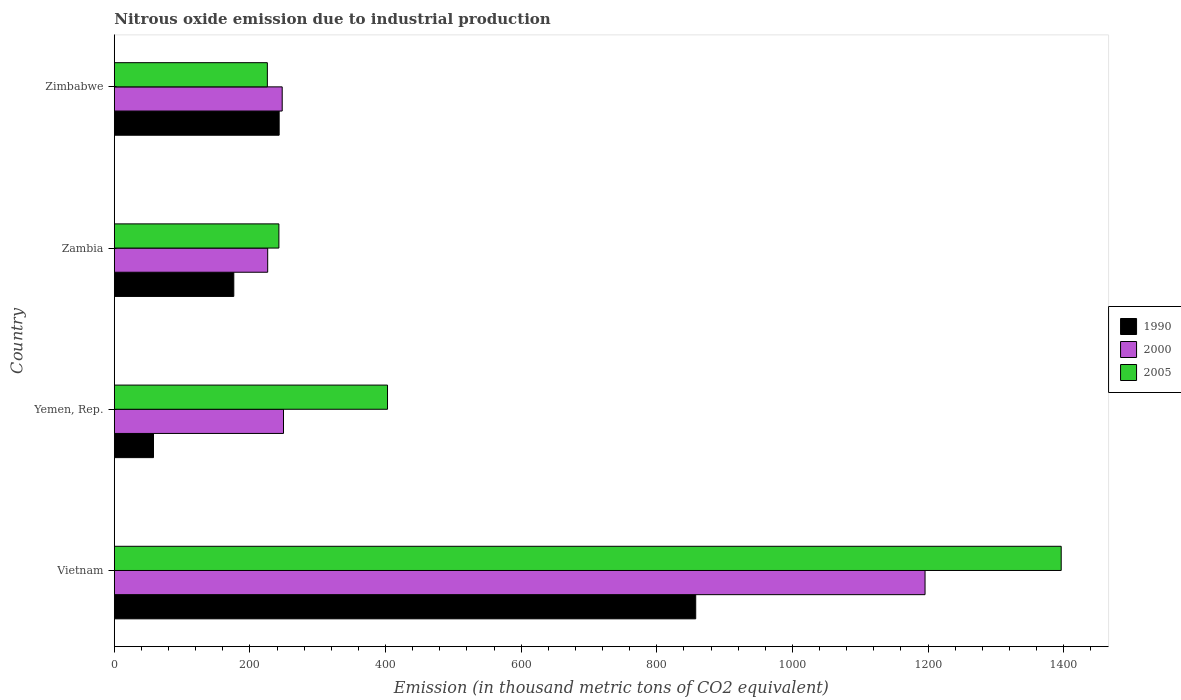How many different coloured bars are there?
Keep it short and to the point. 3. Are the number of bars on each tick of the Y-axis equal?
Ensure brevity in your answer.  Yes. How many bars are there on the 1st tick from the top?
Your answer should be compact. 3. How many bars are there on the 1st tick from the bottom?
Give a very brief answer. 3. What is the label of the 2nd group of bars from the top?
Give a very brief answer. Zambia. What is the amount of nitrous oxide emitted in 1990 in Zambia?
Provide a short and direct response. 176.2. Across all countries, what is the maximum amount of nitrous oxide emitted in 1990?
Provide a short and direct response. 857.4. Across all countries, what is the minimum amount of nitrous oxide emitted in 2000?
Ensure brevity in your answer.  226.2. In which country was the amount of nitrous oxide emitted in 2005 maximum?
Offer a terse response. Vietnam. In which country was the amount of nitrous oxide emitted in 1990 minimum?
Make the answer very short. Yemen, Rep. What is the total amount of nitrous oxide emitted in 1990 in the graph?
Provide a short and direct response. 1334.5. What is the difference between the amount of nitrous oxide emitted in 2005 in Yemen, Rep. and that in Zambia?
Provide a succinct answer. 160.2. What is the difference between the amount of nitrous oxide emitted in 2005 in Vietnam and the amount of nitrous oxide emitted in 1990 in Zambia?
Offer a terse response. 1220.2. What is the average amount of nitrous oxide emitted in 2000 per country?
Offer a terse response. 479.72. What is the difference between the amount of nitrous oxide emitted in 2000 and amount of nitrous oxide emitted in 1990 in Vietnam?
Offer a very short reply. 338.2. In how many countries, is the amount of nitrous oxide emitted in 1990 greater than 1400 thousand metric tons?
Keep it short and to the point. 0. What is the ratio of the amount of nitrous oxide emitted in 1990 in Yemen, Rep. to that in Zambia?
Provide a short and direct response. 0.33. Is the difference between the amount of nitrous oxide emitted in 2000 in Yemen, Rep. and Zambia greater than the difference between the amount of nitrous oxide emitted in 1990 in Yemen, Rep. and Zambia?
Your response must be concise. Yes. What is the difference between the highest and the second highest amount of nitrous oxide emitted in 2000?
Your response must be concise. 946.1. What is the difference between the highest and the lowest amount of nitrous oxide emitted in 2000?
Provide a succinct answer. 969.4. What does the 1st bar from the bottom in Yemen, Rep. represents?
Offer a terse response. 1990. Is it the case that in every country, the sum of the amount of nitrous oxide emitted in 1990 and amount of nitrous oxide emitted in 2005 is greater than the amount of nitrous oxide emitted in 2000?
Provide a short and direct response. Yes. How many countries are there in the graph?
Keep it short and to the point. 4. What is the difference between two consecutive major ticks on the X-axis?
Your answer should be very brief. 200. Does the graph contain any zero values?
Your response must be concise. No. Where does the legend appear in the graph?
Provide a succinct answer. Center right. What is the title of the graph?
Provide a succinct answer. Nitrous oxide emission due to industrial production. Does "1979" appear as one of the legend labels in the graph?
Offer a terse response. No. What is the label or title of the X-axis?
Provide a short and direct response. Emission (in thousand metric tons of CO2 equivalent). What is the label or title of the Y-axis?
Your answer should be very brief. Country. What is the Emission (in thousand metric tons of CO2 equivalent) of 1990 in Vietnam?
Provide a succinct answer. 857.4. What is the Emission (in thousand metric tons of CO2 equivalent) in 2000 in Vietnam?
Give a very brief answer. 1195.6. What is the Emission (in thousand metric tons of CO2 equivalent) in 2005 in Vietnam?
Make the answer very short. 1396.4. What is the Emission (in thousand metric tons of CO2 equivalent) in 1990 in Yemen, Rep.?
Give a very brief answer. 57.8. What is the Emission (in thousand metric tons of CO2 equivalent) in 2000 in Yemen, Rep.?
Offer a very short reply. 249.5. What is the Emission (in thousand metric tons of CO2 equivalent) in 2005 in Yemen, Rep.?
Give a very brief answer. 402.9. What is the Emission (in thousand metric tons of CO2 equivalent) in 1990 in Zambia?
Your answer should be compact. 176.2. What is the Emission (in thousand metric tons of CO2 equivalent) of 2000 in Zambia?
Make the answer very short. 226.2. What is the Emission (in thousand metric tons of CO2 equivalent) of 2005 in Zambia?
Make the answer very short. 242.7. What is the Emission (in thousand metric tons of CO2 equivalent) in 1990 in Zimbabwe?
Ensure brevity in your answer.  243.1. What is the Emission (in thousand metric tons of CO2 equivalent) of 2000 in Zimbabwe?
Your response must be concise. 247.6. What is the Emission (in thousand metric tons of CO2 equivalent) of 2005 in Zimbabwe?
Keep it short and to the point. 225.7. Across all countries, what is the maximum Emission (in thousand metric tons of CO2 equivalent) in 1990?
Offer a very short reply. 857.4. Across all countries, what is the maximum Emission (in thousand metric tons of CO2 equivalent) of 2000?
Provide a succinct answer. 1195.6. Across all countries, what is the maximum Emission (in thousand metric tons of CO2 equivalent) in 2005?
Your answer should be very brief. 1396.4. Across all countries, what is the minimum Emission (in thousand metric tons of CO2 equivalent) in 1990?
Offer a terse response. 57.8. Across all countries, what is the minimum Emission (in thousand metric tons of CO2 equivalent) in 2000?
Your response must be concise. 226.2. Across all countries, what is the minimum Emission (in thousand metric tons of CO2 equivalent) of 2005?
Keep it short and to the point. 225.7. What is the total Emission (in thousand metric tons of CO2 equivalent) of 1990 in the graph?
Give a very brief answer. 1334.5. What is the total Emission (in thousand metric tons of CO2 equivalent) in 2000 in the graph?
Offer a terse response. 1918.9. What is the total Emission (in thousand metric tons of CO2 equivalent) in 2005 in the graph?
Your answer should be very brief. 2267.7. What is the difference between the Emission (in thousand metric tons of CO2 equivalent) in 1990 in Vietnam and that in Yemen, Rep.?
Your answer should be compact. 799.6. What is the difference between the Emission (in thousand metric tons of CO2 equivalent) of 2000 in Vietnam and that in Yemen, Rep.?
Provide a succinct answer. 946.1. What is the difference between the Emission (in thousand metric tons of CO2 equivalent) in 2005 in Vietnam and that in Yemen, Rep.?
Keep it short and to the point. 993.5. What is the difference between the Emission (in thousand metric tons of CO2 equivalent) of 1990 in Vietnam and that in Zambia?
Ensure brevity in your answer.  681.2. What is the difference between the Emission (in thousand metric tons of CO2 equivalent) of 2000 in Vietnam and that in Zambia?
Provide a short and direct response. 969.4. What is the difference between the Emission (in thousand metric tons of CO2 equivalent) of 2005 in Vietnam and that in Zambia?
Your answer should be compact. 1153.7. What is the difference between the Emission (in thousand metric tons of CO2 equivalent) of 1990 in Vietnam and that in Zimbabwe?
Offer a very short reply. 614.3. What is the difference between the Emission (in thousand metric tons of CO2 equivalent) in 2000 in Vietnam and that in Zimbabwe?
Your response must be concise. 948. What is the difference between the Emission (in thousand metric tons of CO2 equivalent) in 2005 in Vietnam and that in Zimbabwe?
Offer a very short reply. 1170.7. What is the difference between the Emission (in thousand metric tons of CO2 equivalent) of 1990 in Yemen, Rep. and that in Zambia?
Make the answer very short. -118.4. What is the difference between the Emission (in thousand metric tons of CO2 equivalent) of 2000 in Yemen, Rep. and that in Zambia?
Your response must be concise. 23.3. What is the difference between the Emission (in thousand metric tons of CO2 equivalent) of 2005 in Yemen, Rep. and that in Zambia?
Give a very brief answer. 160.2. What is the difference between the Emission (in thousand metric tons of CO2 equivalent) in 1990 in Yemen, Rep. and that in Zimbabwe?
Provide a short and direct response. -185.3. What is the difference between the Emission (in thousand metric tons of CO2 equivalent) of 2000 in Yemen, Rep. and that in Zimbabwe?
Provide a succinct answer. 1.9. What is the difference between the Emission (in thousand metric tons of CO2 equivalent) in 2005 in Yemen, Rep. and that in Zimbabwe?
Offer a very short reply. 177.2. What is the difference between the Emission (in thousand metric tons of CO2 equivalent) in 1990 in Zambia and that in Zimbabwe?
Give a very brief answer. -66.9. What is the difference between the Emission (in thousand metric tons of CO2 equivalent) in 2000 in Zambia and that in Zimbabwe?
Your answer should be very brief. -21.4. What is the difference between the Emission (in thousand metric tons of CO2 equivalent) in 1990 in Vietnam and the Emission (in thousand metric tons of CO2 equivalent) in 2000 in Yemen, Rep.?
Offer a terse response. 607.9. What is the difference between the Emission (in thousand metric tons of CO2 equivalent) in 1990 in Vietnam and the Emission (in thousand metric tons of CO2 equivalent) in 2005 in Yemen, Rep.?
Offer a terse response. 454.5. What is the difference between the Emission (in thousand metric tons of CO2 equivalent) of 2000 in Vietnam and the Emission (in thousand metric tons of CO2 equivalent) of 2005 in Yemen, Rep.?
Give a very brief answer. 792.7. What is the difference between the Emission (in thousand metric tons of CO2 equivalent) of 1990 in Vietnam and the Emission (in thousand metric tons of CO2 equivalent) of 2000 in Zambia?
Give a very brief answer. 631.2. What is the difference between the Emission (in thousand metric tons of CO2 equivalent) of 1990 in Vietnam and the Emission (in thousand metric tons of CO2 equivalent) of 2005 in Zambia?
Offer a terse response. 614.7. What is the difference between the Emission (in thousand metric tons of CO2 equivalent) of 2000 in Vietnam and the Emission (in thousand metric tons of CO2 equivalent) of 2005 in Zambia?
Your answer should be very brief. 952.9. What is the difference between the Emission (in thousand metric tons of CO2 equivalent) of 1990 in Vietnam and the Emission (in thousand metric tons of CO2 equivalent) of 2000 in Zimbabwe?
Keep it short and to the point. 609.8. What is the difference between the Emission (in thousand metric tons of CO2 equivalent) in 1990 in Vietnam and the Emission (in thousand metric tons of CO2 equivalent) in 2005 in Zimbabwe?
Your response must be concise. 631.7. What is the difference between the Emission (in thousand metric tons of CO2 equivalent) of 2000 in Vietnam and the Emission (in thousand metric tons of CO2 equivalent) of 2005 in Zimbabwe?
Give a very brief answer. 969.9. What is the difference between the Emission (in thousand metric tons of CO2 equivalent) of 1990 in Yemen, Rep. and the Emission (in thousand metric tons of CO2 equivalent) of 2000 in Zambia?
Provide a short and direct response. -168.4. What is the difference between the Emission (in thousand metric tons of CO2 equivalent) of 1990 in Yemen, Rep. and the Emission (in thousand metric tons of CO2 equivalent) of 2005 in Zambia?
Provide a short and direct response. -184.9. What is the difference between the Emission (in thousand metric tons of CO2 equivalent) in 2000 in Yemen, Rep. and the Emission (in thousand metric tons of CO2 equivalent) in 2005 in Zambia?
Offer a very short reply. 6.8. What is the difference between the Emission (in thousand metric tons of CO2 equivalent) of 1990 in Yemen, Rep. and the Emission (in thousand metric tons of CO2 equivalent) of 2000 in Zimbabwe?
Offer a very short reply. -189.8. What is the difference between the Emission (in thousand metric tons of CO2 equivalent) in 1990 in Yemen, Rep. and the Emission (in thousand metric tons of CO2 equivalent) in 2005 in Zimbabwe?
Your answer should be compact. -167.9. What is the difference between the Emission (in thousand metric tons of CO2 equivalent) in 2000 in Yemen, Rep. and the Emission (in thousand metric tons of CO2 equivalent) in 2005 in Zimbabwe?
Give a very brief answer. 23.8. What is the difference between the Emission (in thousand metric tons of CO2 equivalent) of 1990 in Zambia and the Emission (in thousand metric tons of CO2 equivalent) of 2000 in Zimbabwe?
Offer a terse response. -71.4. What is the difference between the Emission (in thousand metric tons of CO2 equivalent) of 1990 in Zambia and the Emission (in thousand metric tons of CO2 equivalent) of 2005 in Zimbabwe?
Ensure brevity in your answer.  -49.5. What is the difference between the Emission (in thousand metric tons of CO2 equivalent) in 2000 in Zambia and the Emission (in thousand metric tons of CO2 equivalent) in 2005 in Zimbabwe?
Your response must be concise. 0.5. What is the average Emission (in thousand metric tons of CO2 equivalent) of 1990 per country?
Your answer should be compact. 333.62. What is the average Emission (in thousand metric tons of CO2 equivalent) of 2000 per country?
Make the answer very short. 479.73. What is the average Emission (in thousand metric tons of CO2 equivalent) of 2005 per country?
Offer a very short reply. 566.92. What is the difference between the Emission (in thousand metric tons of CO2 equivalent) in 1990 and Emission (in thousand metric tons of CO2 equivalent) in 2000 in Vietnam?
Give a very brief answer. -338.2. What is the difference between the Emission (in thousand metric tons of CO2 equivalent) of 1990 and Emission (in thousand metric tons of CO2 equivalent) of 2005 in Vietnam?
Offer a terse response. -539. What is the difference between the Emission (in thousand metric tons of CO2 equivalent) of 2000 and Emission (in thousand metric tons of CO2 equivalent) of 2005 in Vietnam?
Your response must be concise. -200.8. What is the difference between the Emission (in thousand metric tons of CO2 equivalent) in 1990 and Emission (in thousand metric tons of CO2 equivalent) in 2000 in Yemen, Rep.?
Make the answer very short. -191.7. What is the difference between the Emission (in thousand metric tons of CO2 equivalent) in 1990 and Emission (in thousand metric tons of CO2 equivalent) in 2005 in Yemen, Rep.?
Provide a short and direct response. -345.1. What is the difference between the Emission (in thousand metric tons of CO2 equivalent) of 2000 and Emission (in thousand metric tons of CO2 equivalent) of 2005 in Yemen, Rep.?
Provide a short and direct response. -153.4. What is the difference between the Emission (in thousand metric tons of CO2 equivalent) in 1990 and Emission (in thousand metric tons of CO2 equivalent) in 2000 in Zambia?
Your answer should be very brief. -50. What is the difference between the Emission (in thousand metric tons of CO2 equivalent) in 1990 and Emission (in thousand metric tons of CO2 equivalent) in 2005 in Zambia?
Your response must be concise. -66.5. What is the difference between the Emission (in thousand metric tons of CO2 equivalent) of 2000 and Emission (in thousand metric tons of CO2 equivalent) of 2005 in Zambia?
Your answer should be very brief. -16.5. What is the difference between the Emission (in thousand metric tons of CO2 equivalent) in 2000 and Emission (in thousand metric tons of CO2 equivalent) in 2005 in Zimbabwe?
Make the answer very short. 21.9. What is the ratio of the Emission (in thousand metric tons of CO2 equivalent) of 1990 in Vietnam to that in Yemen, Rep.?
Offer a very short reply. 14.83. What is the ratio of the Emission (in thousand metric tons of CO2 equivalent) in 2000 in Vietnam to that in Yemen, Rep.?
Your response must be concise. 4.79. What is the ratio of the Emission (in thousand metric tons of CO2 equivalent) in 2005 in Vietnam to that in Yemen, Rep.?
Your answer should be compact. 3.47. What is the ratio of the Emission (in thousand metric tons of CO2 equivalent) of 1990 in Vietnam to that in Zambia?
Ensure brevity in your answer.  4.87. What is the ratio of the Emission (in thousand metric tons of CO2 equivalent) of 2000 in Vietnam to that in Zambia?
Your response must be concise. 5.29. What is the ratio of the Emission (in thousand metric tons of CO2 equivalent) of 2005 in Vietnam to that in Zambia?
Your response must be concise. 5.75. What is the ratio of the Emission (in thousand metric tons of CO2 equivalent) in 1990 in Vietnam to that in Zimbabwe?
Your answer should be compact. 3.53. What is the ratio of the Emission (in thousand metric tons of CO2 equivalent) of 2000 in Vietnam to that in Zimbabwe?
Your answer should be very brief. 4.83. What is the ratio of the Emission (in thousand metric tons of CO2 equivalent) in 2005 in Vietnam to that in Zimbabwe?
Ensure brevity in your answer.  6.19. What is the ratio of the Emission (in thousand metric tons of CO2 equivalent) of 1990 in Yemen, Rep. to that in Zambia?
Provide a succinct answer. 0.33. What is the ratio of the Emission (in thousand metric tons of CO2 equivalent) of 2000 in Yemen, Rep. to that in Zambia?
Your answer should be very brief. 1.1. What is the ratio of the Emission (in thousand metric tons of CO2 equivalent) in 2005 in Yemen, Rep. to that in Zambia?
Keep it short and to the point. 1.66. What is the ratio of the Emission (in thousand metric tons of CO2 equivalent) in 1990 in Yemen, Rep. to that in Zimbabwe?
Your response must be concise. 0.24. What is the ratio of the Emission (in thousand metric tons of CO2 equivalent) in 2000 in Yemen, Rep. to that in Zimbabwe?
Keep it short and to the point. 1.01. What is the ratio of the Emission (in thousand metric tons of CO2 equivalent) of 2005 in Yemen, Rep. to that in Zimbabwe?
Your response must be concise. 1.79. What is the ratio of the Emission (in thousand metric tons of CO2 equivalent) of 1990 in Zambia to that in Zimbabwe?
Your response must be concise. 0.72. What is the ratio of the Emission (in thousand metric tons of CO2 equivalent) in 2000 in Zambia to that in Zimbabwe?
Offer a terse response. 0.91. What is the ratio of the Emission (in thousand metric tons of CO2 equivalent) in 2005 in Zambia to that in Zimbabwe?
Your response must be concise. 1.08. What is the difference between the highest and the second highest Emission (in thousand metric tons of CO2 equivalent) in 1990?
Your answer should be very brief. 614.3. What is the difference between the highest and the second highest Emission (in thousand metric tons of CO2 equivalent) in 2000?
Offer a very short reply. 946.1. What is the difference between the highest and the second highest Emission (in thousand metric tons of CO2 equivalent) of 2005?
Provide a short and direct response. 993.5. What is the difference between the highest and the lowest Emission (in thousand metric tons of CO2 equivalent) of 1990?
Keep it short and to the point. 799.6. What is the difference between the highest and the lowest Emission (in thousand metric tons of CO2 equivalent) in 2000?
Make the answer very short. 969.4. What is the difference between the highest and the lowest Emission (in thousand metric tons of CO2 equivalent) of 2005?
Offer a terse response. 1170.7. 